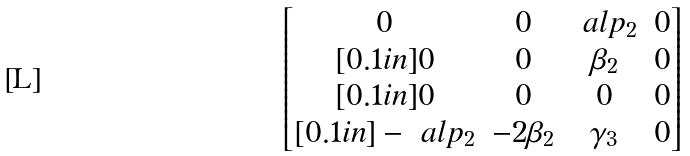Convert formula to latex. <formula><loc_0><loc_0><loc_500><loc_500>\begin{bmatrix} 0 & 0 & \ a l p _ { 2 } & 0 \\ [ 0 . 1 i n ] 0 & 0 & \beta _ { 2 } & 0 \\ [ 0 . 1 i n ] 0 & 0 & 0 & 0 \\ [ 0 . 1 i n ] - \ a l p _ { 2 } & - 2 \beta _ { 2 } & \gamma _ { 3 } & 0 \end{bmatrix}</formula> 